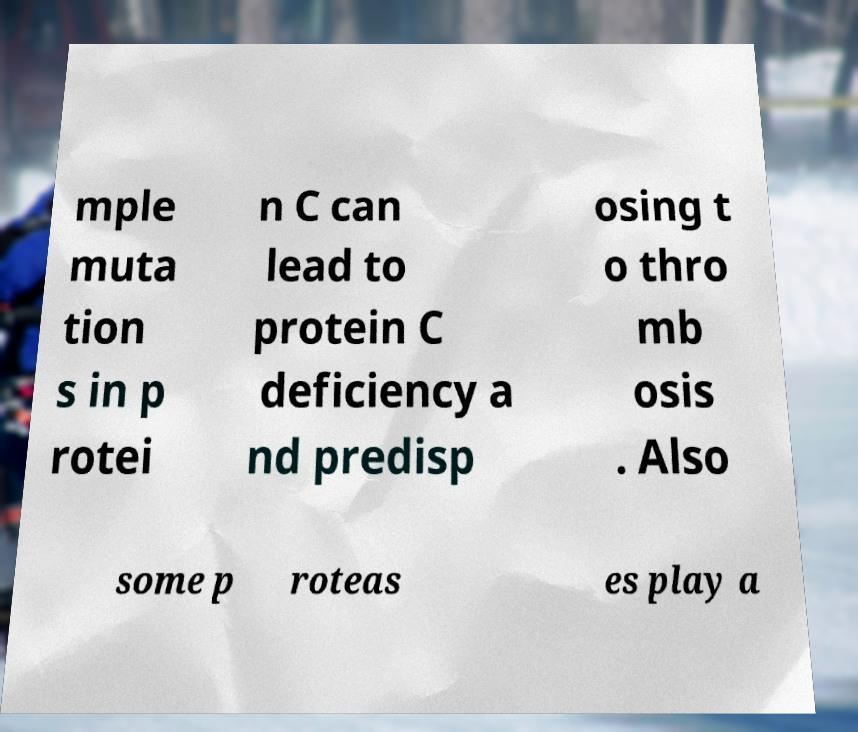Please read and relay the text visible in this image. What does it say? mple muta tion s in p rotei n C can lead to protein C deficiency a nd predisp osing t o thro mb osis . Also some p roteas es play a 